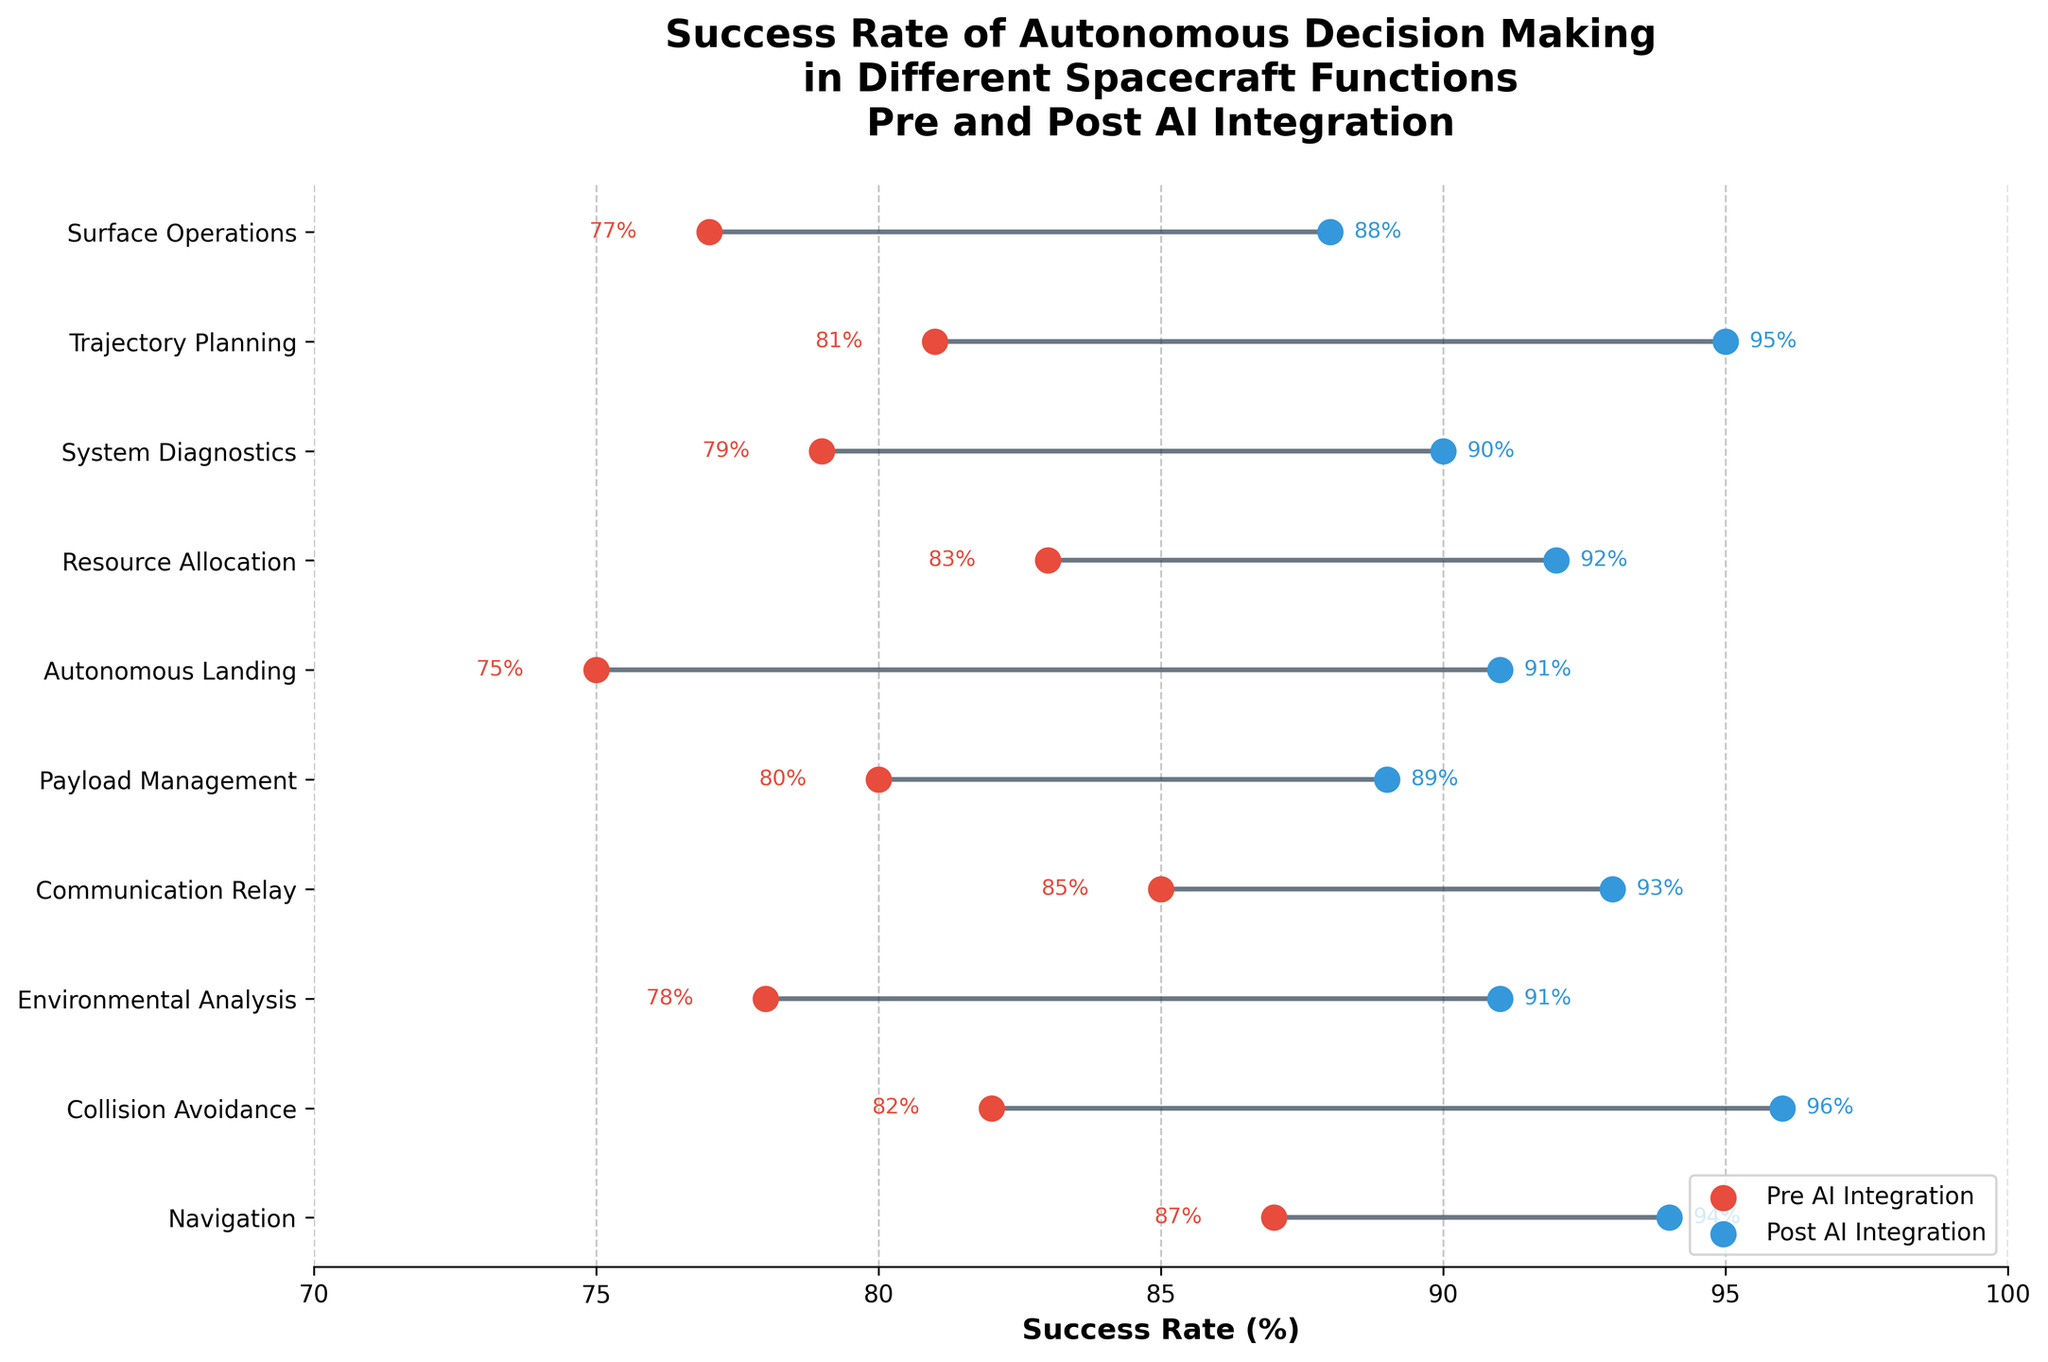what is the title of the figure? To find the title of the figure, look at the text displayed prominently at the top of the plot. It is usually in larger font and bold compared to other text elements.
Answer: Success Rate of Autonomous Decision Making in Different Spacecraft Functions Pre and Post AI Integration What colors represent pre and post AI integration success rates? The colors can be identified by looking at the legend displayed within the plot. The legend shows two colors with their corresponding labels: Pre AI Integration and Post AI Integration.
Answer: Red and Blue How many spacecraft functions are compared in this plot? To find the number of spacecraft functions compared, count the number of y-axis labels as each represents a different spacecraft function.
Answer: 10 Which spacecraft function shows the greatest improvement in success rate after AI integration? To find the greatest improvement, compute the difference between pre and post AI integration success rates for each function and identify the largest value. For instance, Autonomous Landing improves from 75% to 91%, a difference of 16%. This process is repeated across all functions.
Answer: Autonomous Landing What is the average success rate for System Diagnostics before and after AI integration? To find the average success rate for System Diagnostics, first fetch the pre and post AI integration success rates from the plot: 79% and 90%, respectively. Then compute their average. (79 + 90) / 2 = 169 / 2 = 84.5
Answer: 84.5% Which spacecraft function has the highest success rate after AI integration? Look at the blue dots on the plot corresponding to post AI integration success rates and identify the highest value. For example, Trajectory Planning (95%).
Answer: Trajectory Planning By how much did the success rate of Collision Avoidance increase after AI integration? Identify the pre and post AI integration success rates for Collision Avoidance from the plot: 82% and 96%. Calculate the increase: 96 - 82 = 14
Answer: 14% Which two spacecraft functions have the lowest success rate before AI integration, and what are their success rates? To find the two functions with the lowest pre-AI success rates, look at the red dots and identify the smallest two values. Autonomous Landing (75%) and Environmental Analysis (78%).
Answer: Autonomous Landing (75%) and Environmental Analysis (78%) Is the success rate for any spacecraft function equal before and after AI integration? Check the pre and post AI integration success rates for all spacecraft functions to see if any pair is equal. In this plot, none of the pre- and post-rates are equal.
Answer: No Which spacecraft function shows the least improvement in success rate after AI integration, and what is the amount of improvement? Calculate the difference between pre and post AI integration success rates for each function, and identify the smallest value. In this case, Communication Relay improves from 85% to 93%, a difference of 8%.
Answer: Communication Relay, 8% 